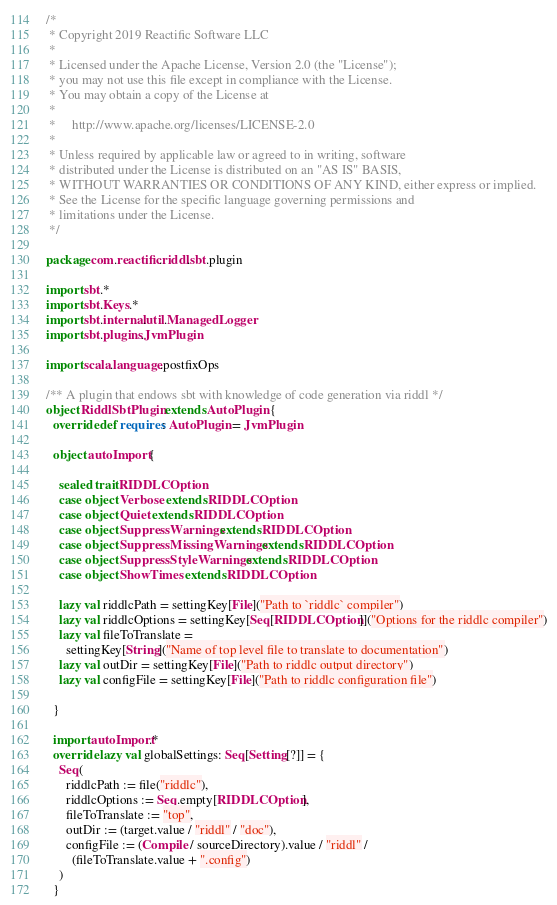<code> <loc_0><loc_0><loc_500><loc_500><_Scala_>/*
 * Copyright 2019 Reactific Software LLC
 *
 * Licensed under the Apache License, Version 2.0 (the "License");
 * you may not use this file except in compliance with the License.
 * You may obtain a copy of the License at
 *
 *     http://www.apache.org/licenses/LICENSE-2.0
 *
 * Unless required by applicable law or agreed to in writing, software
 * distributed under the License is distributed on an "AS IS" BASIS,
 * WITHOUT WARRANTIES OR CONDITIONS OF ANY KIND, either express or implied.
 * See the License for the specific language governing permissions and
 * limitations under the License.
 */

package com.reactific.riddl.sbt.plugin

import sbt.*
import sbt.Keys.*
import sbt.internal.util.ManagedLogger
import sbt.plugins.JvmPlugin

import scala.language.postfixOps

/** A plugin that endows sbt with knowledge of code generation via riddl */
object RiddlSbtPlugin extends AutoPlugin {
  override def requires: AutoPlugin = JvmPlugin

  object autoImport {

    sealed trait RIDDLCOption
    case object Verbose extends RIDDLCOption
    case object Quiet extends RIDDLCOption
    case object SuppressWarnings extends RIDDLCOption
    case object SuppressMissingWarnings extends RIDDLCOption
    case object SuppressStyleWarnings extends RIDDLCOption
    case object ShowTimes extends RIDDLCOption

    lazy val riddlcPath = settingKey[File]("Path to `riddlc` compiler")
    lazy val riddlcOptions = settingKey[Seq[RIDDLCOption]]("Options for the riddlc compiler")
    lazy val fileToTranslate =
      settingKey[String]("Name of top level file to translate to documentation")
    lazy val outDir = settingKey[File]("Path to riddlc output directory")
    lazy val configFile = settingKey[File]("Path to riddlc configuration file")

  }

  import autoImport.*
  override lazy val globalSettings: Seq[Setting[?]] = {
    Seq(
      riddlcPath := file("riddlc"),
      riddlcOptions := Seq.empty[RIDDLCOption],
      fileToTranslate := "top",
      outDir := (target.value / "riddl" / "doc"),
      configFile := (Compile / sourceDirectory).value / "riddl" /
        (fileToTranslate.value + ".config")
    )
  }
</code> 